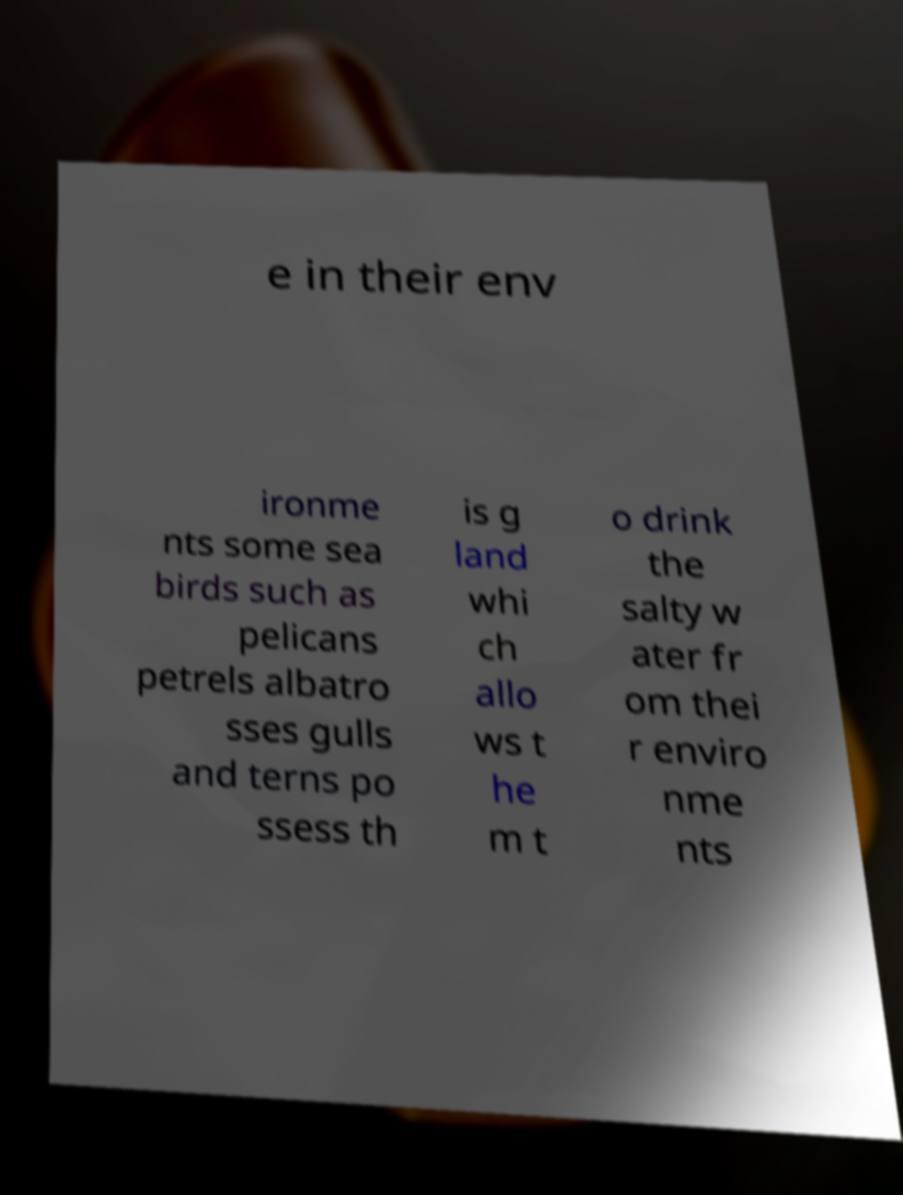Could you extract and type out the text from this image? e in their env ironme nts some sea birds such as pelicans petrels albatro sses gulls and terns po ssess th is g land whi ch allo ws t he m t o drink the salty w ater fr om thei r enviro nme nts 